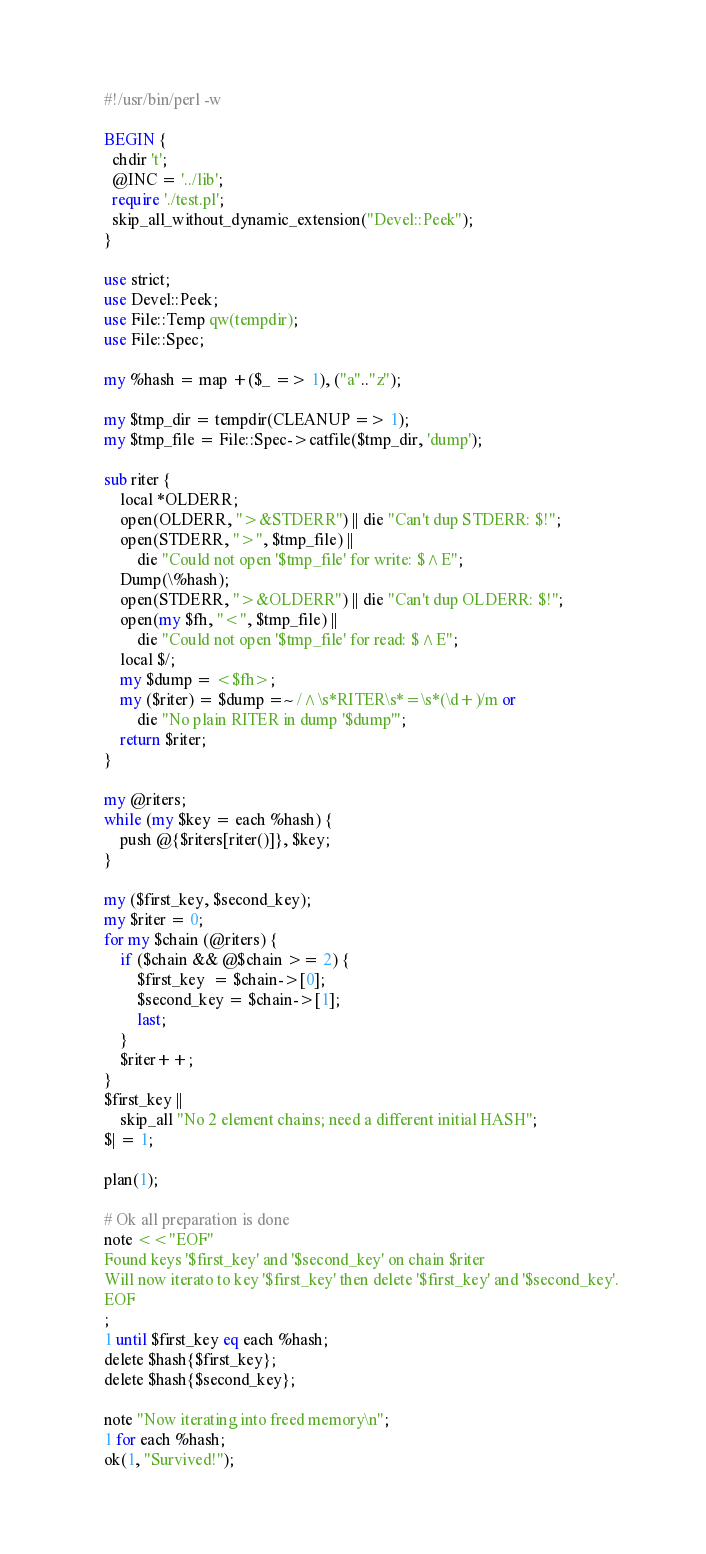Convert code to text. <code><loc_0><loc_0><loc_500><loc_500><_Perl_>#!/usr/bin/perl -w

BEGIN {
  chdir 't';
  @INC = '../lib';
  require './test.pl';
  skip_all_without_dynamic_extension("Devel::Peek");
}

use strict;
use Devel::Peek;
use File::Temp qw(tempdir);
use File::Spec;

my %hash = map +($_ => 1), ("a".."z");

my $tmp_dir = tempdir(CLEANUP => 1);
my $tmp_file = File::Spec->catfile($tmp_dir, 'dump');

sub riter {
    local *OLDERR;
    open(OLDERR, ">&STDERR") || die "Can't dup STDERR: $!";
    open(STDERR, ">", $tmp_file) ||
        die "Could not open '$tmp_file' for write: $^E";
    Dump(\%hash);
    open(STDERR, ">&OLDERR") || die "Can't dup OLDERR: $!";
    open(my $fh, "<", $tmp_file) ||
        die "Could not open '$tmp_file' for read: $^E";
    local $/;
    my $dump = <$fh>;
    my ($riter) = $dump =~ /^\s*RITER\s*=\s*(\d+)/m or
        die "No plain RITER in dump '$dump'";
    return $riter;
}

my @riters;
while (my $key = each %hash) {
    push @{$riters[riter()]}, $key;
}

my ($first_key, $second_key);
my $riter = 0;
for my $chain (@riters) {
    if ($chain && @$chain >= 2) {
        $first_key  = $chain->[0];
        $second_key = $chain->[1];
        last;
    }
    $riter++;
}
$first_key ||
    skip_all "No 2 element chains; need a different initial HASH";
$| = 1;

plan(1);

# Ok all preparation is done
note <<"EOF"
Found keys '$first_key' and '$second_key' on chain $riter
Will now iterato to key '$first_key' then delete '$first_key' and '$second_key'.
EOF
;
1 until $first_key eq each %hash;
delete $hash{$first_key};
delete $hash{$second_key};

note "Now iterating into freed memory\n";
1 for each %hash;
ok(1, "Survived!");
</code> 